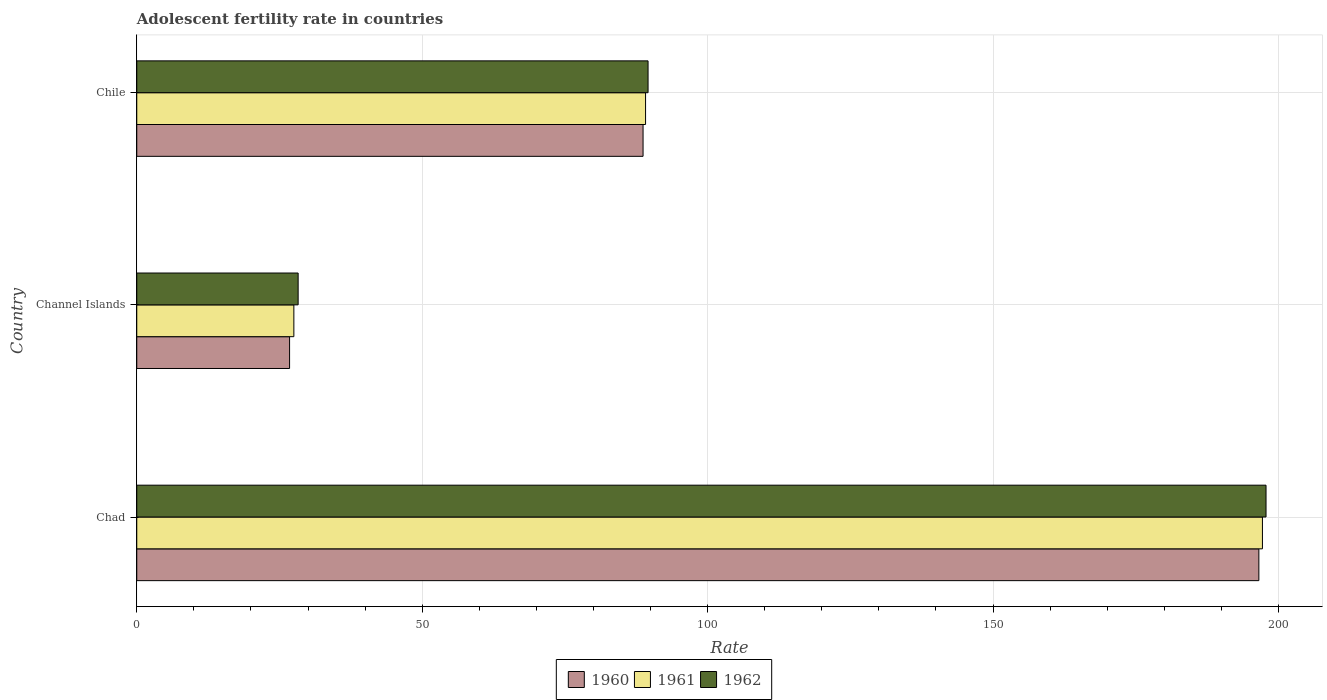How many different coloured bars are there?
Your answer should be compact. 3. How many bars are there on the 3rd tick from the top?
Make the answer very short. 3. How many bars are there on the 2nd tick from the bottom?
Provide a short and direct response. 3. What is the label of the 2nd group of bars from the top?
Ensure brevity in your answer.  Channel Islands. What is the adolescent fertility rate in 1962 in Chad?
Keep it short and to the point. 197.82. Across all countries, what is the maximum adolescent fertility rate in 1961?
Your response must be concise. 197.19. Across all countries, what is the minimum adolescent fertility rate in 1960?
Provide a succinct answer. 26.77. In which country was the adolescent fertility rate in 1962 maximum?
Keep it short and to the point. Chad. In which country was the adolescent fertility rate in 1961 minimum?
Your response must be concise. Channel Islands. What is the total adolescent fertility rate in 1961 in the graph?
Provide a succinct answer. 313.84. What is the difference between the adolescent fertility rate in 1960 in Chad and that in Channel Islands?
Offer a very short reply. 169.8. What is the difference between the adolescent fertility rate in 1960 in Chile and the adolescent fertility rate in 1961 in Channel Islands?
Your answer should be very brief. 61.17. What is the average adolescent fertility rate in 1962 per country?
Provide a succinct answer. 105.22. What is the difference between the adolescent fertility rate in 1960 and adolescent fertility rate in 1962 in Channel Islands?
Make the answer very short. -1.5. What is the ratio of the adolescent fertility rate in 1961 in Chad to that in Channel Islands?
Your answer should be very brief. 7.17. Is the adolescent fertility rate in 1962 in Chad less than that in Chile?
Provide a short and direct response. No. What is the difference between the highest and the second highest adolescent fertility rate in 1961?
Your response must be concise. 108.06. What is the difference between the highest and the lowest adolescent fertility rate in 1960?
Offer a very short reply. 169.8. In how many countries, is the adolescent fertility rate in 1960 greater than the average adolescent fertility rate in 1960 taken over all countries?
Keep it short and to the point. 1. Is it the case that in every country, the sum of the adolescent fertility rate in 1961 and adolescent fertility rate in 1962 is greater than the adolescent fertility rate in 1960?
Ensure brevity in your answer.  Yes. What is the difference between two consecutive major ticks on the X-axis?
Provide a succinct answer. 50. Are the values on the major ticks of X-axis written in scientific E-notation?
Offer a very short reply. No. Does the graph contain any zero values?
Offer a very short reply. No. What is the title of the graph?
Ensure brevity in your answer.  Adolescent fertility rate in countries. What is the label or title of the X-axis?
Your answer should be very brief. Rate. What is the Rate of 1960 in Chad?
Provide a short and direct response. 196.56. What is the Rate in 1961 in Chad?
Offer a very short reply. 197.19. What is the Rate of 1962 in Chad?
Your answer should be compact. 197.82. What is the Rate in 1960 in Channel Islands?
Give a very brief answer. 26.77. What is the Rate in 1961 in Channel Islands?
Offer a very short reply. 27.52. What is the Rate of 1962 in Channel Islands?
Provide a succinct answer. 28.27. What is the Rate of 1960 in Chile?
Keep it short and to the point. 88.69. What is the Rate in 1961 in Chile?
Offer a terse response. 89.13. What is the Rate of 1962 in Chile?
Your answer should be very brief. 89.57. Across all countries, what is the maximum Rate of 1960?
Offer a terse response. 196.56. Across all countries, what is the maximum Rate of 1961?
Provide a short and direct response. 197.19. Across all countries, what is the maximum Rate of 1962?
Offer a very short reply. 197.82. Across all countries, what is the minimum Rate of 1960?
Make the answer very short. 26.77. Across all countries, what is the minimum Rate of 1961?
Keep it short and to the point. 27.52. Across all countries, what is the minimum Rate of 1962?
Provide a short and direct response. 28.27. What is the total Rate of 1960 in the graph?
Provide a succinct answer. 312.02. What is the total Rate in 1961 in the graph?
Give a very brief answer. 313.84. What is the total Rate of 1962 in the graph?
Provide a succinct answer. 315.66. What is the difference between the Rate of 1960 in Chad and that in Channel Islands?
Keep it short and to the point. 169.8. What is the difference between the Rate in 1961 in Chad and that in Channel Islands?
Provide a short and direct response. 169.67. What is the difference between the Rate of 1962 in Chad and that in Channel Islands?
Make the answer very short. 169.55. What is the difference between the Rate of 1960 in Chad and that in Chile?
Keep it short and to the point. 107.87. What is the difference between the Rate in 1961 in Chad and that in Chile?
Give a very brief answer. 108.06. What is the difference between the Rate in 1962 in Chad and that in Chile?
Make the answer very short. 108.25. What is the difference between the Rate of 1960 in Channel Islands and that in Chile?
Offer a terse response. -61.92. What is the difference between the Rate in 1961 in Channel Islands and that in Chile?
Offer a very short reply. -61.61. What is the difference between the Rate of 1962 in Channel Islands and that in Chile?
Ensure brevity in your answer.  -61.3. What is the difference between the Rate in 1960 in Chad and the Rate in 1961 in Channel Islands?
Your answer should be very brief. 169.05. What is the difference between the Rate in 1960 in Chad and the Rate in 1962 in Channel Islands?
Keep it short and to the point. 168.29. What is the difference between the Rate of 1961 in Chad and the Rate of 1962 in Channel Islands?
Give a very brief answer. 168.92. What is the difference between the Rate in 1960 in Chad and the Rate in 1961 in Chile?
Make the answer very short. 107.43. What is the difference between the Rate of 1960 in Chad and the Rate of 1962 in Chile?
Provide a short and direct response. 107. What is the difference between the Rate in 1961 in Chad and the Rate in 1962 in Chile?
Offer a terse response. 107.62. What is the difference between the Rate of 1960 in Channel Islands and the Rate of 1961 in Chile?
Your response must be concise. -62.36. What is the difference between the Rate in 1960 in Channel Islands and the Rate in 1962 in Chile?
Give a very brief answer. -62.8. What is the difference between the Rate in 1961 in Channel Islands and the Rate in 1962 in Chile?
Provide a short and direct response. -62.05. What is the average Rate of 1960 per country?
Ensure brevity in your answer.  104.01. What is the average Rate of 1961 per country?
Your answer should be compact. 104.61. What is the average Rate of 1962 per country?
Provide a short and direct response. 105.22. What is the difference between the Rate of 1960 and Rate of 1961 in Chad?
Offer a terse response. -0.63. What is the difference between the Rate in 1960 and Rate in 1962 in Chad?
Make the answer very short. -1.26. What is the difference between the Rate of 1961 and Rate of 1962 in Chad?
Offer a very short reply. -0.63. What is the difference between the Rate in 1960 and Rate in 1961 in Channel Islands?
Provide a short and direct response. -0.75. What is the difference between the Rate of 1960 and Rate of 1962 in Channel Islands?
Provide a succinct answer. -1.5. What is the difference between the Rate of 1961 and Rate of 1962 in Channel Islands?
Your answer should be compact. -0.75. What is the difference between the Rate in 1960 and Rate in 1961 in Chile?
Keep it short and to the point. -0.44. What is the difference between the Rate in 1960 and Rate in 1962 in Chile?
Provide a short and direct response. -0.88. What is the difference between the Rate in 1961 and Rate in 1962 in Chile?
Give a very brief answer. -0.44. What is the ratio of the Rate in 1960 in Chad to that in Channel Islands?
Offer a terse response. 7.34. What is the ratio of the Rate in 1961 in Chad to that in Channel Islands?
Provide a short and direct response. 7.17. What is the ratio of the Rate in 1962 in Chad to that in Channel Islands?
Ensure brevity in your answer.  7. What is the ratio of the Rate of 1960 in Chad to that in Chile?
Provide a short and direct response. 2.22. What is the ratio of the Rate in 1961 in Chad to that in Chile?
Give a very brief answer. 2.21. What is the ratio of the Rate of 1962 in Chad to that in Chile?
Your response must be concise. 2.21. What is the ratio of the Rate in 1960 in Channel Islands to that in Chile?
Your answer should be compact. 0.3. What is the ratio of the Rate in 1961 in Channel Islands to that in Chile?
Provide a succinct answer. 0.31. What is the ratio of the Rate in 1962 in Channel Islands to that in Chile?
Your answer should be very brief. 0.32. What is the difference between the highest and the second highest Rate in 1960?
Make the answer very short. 107.87. What is the difference between the highest and the second highest Rate of 1961?
Keep it short and to the point. 108.06. What is the difference between the highest and the second highest Rate in 1962?
Provide a short and direct response. 108.25. What is the difference between the highest and the lowest Rate in 1960?
Ensure brevity in your answer.  169.8. What is the difference between the highest and the lowest Rate in 1961?
Your response must be concise. 169.67. What is the difference between the highest and the lowest Rate of 1962?
Your response must be concise. 169.55. 